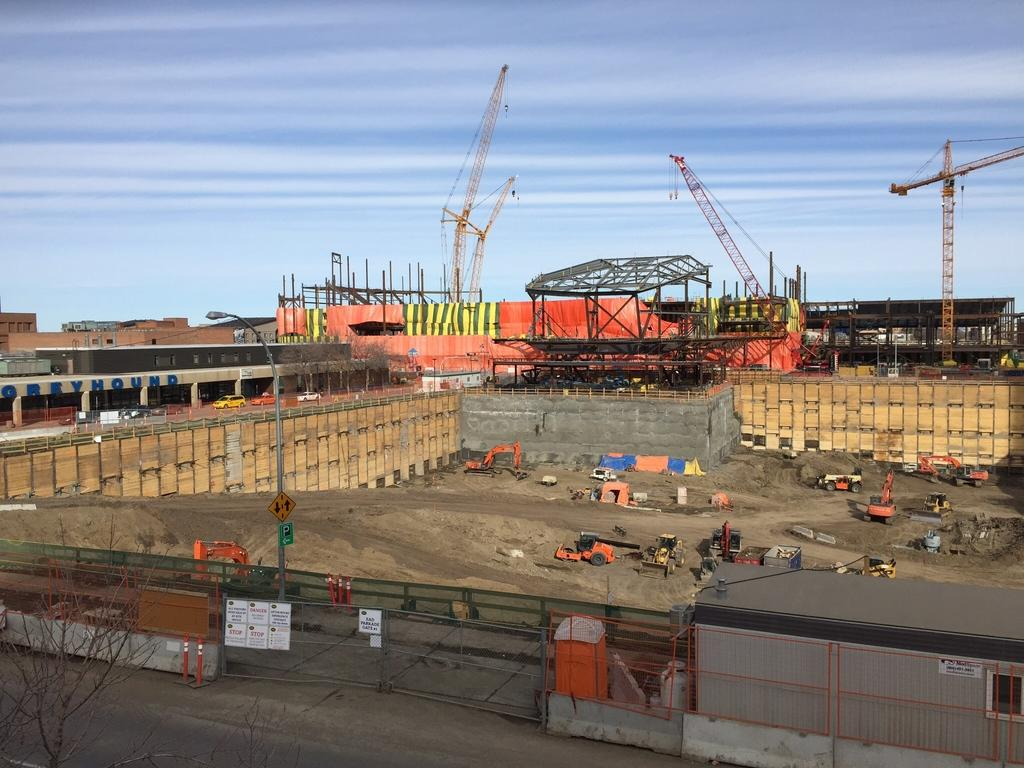What is the main subject of the image? The main subject of the image is a construction site. What equipment can be seen at the construction site? There are cranes at the construction site. What type of barrier is present in the image? There is a fence in the image. What is visible at the top of the image? The sky is visible at the top of the image. How much money is being exchanged between the cranes in the image? There is no exchange of money depicted in the image, as it features a construction site with cranes and a fence. Can you see a snake slithering through the construction site in the image? There is no snake present in the image; it features a construction site with cranes and a fence. 